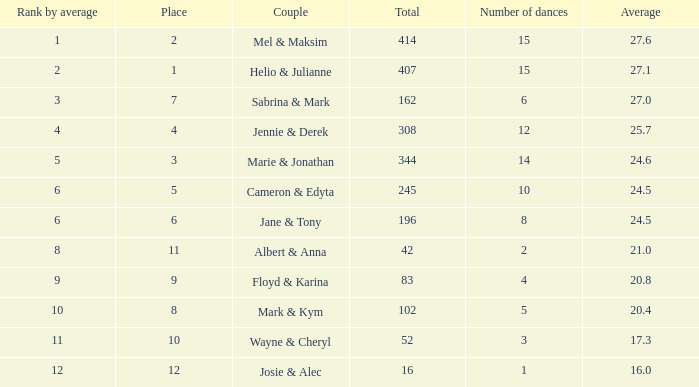In a situation where the total score surpassed 245, the average score was 27.1, and there were under 15 dances, what is the rank based on the average? None. 